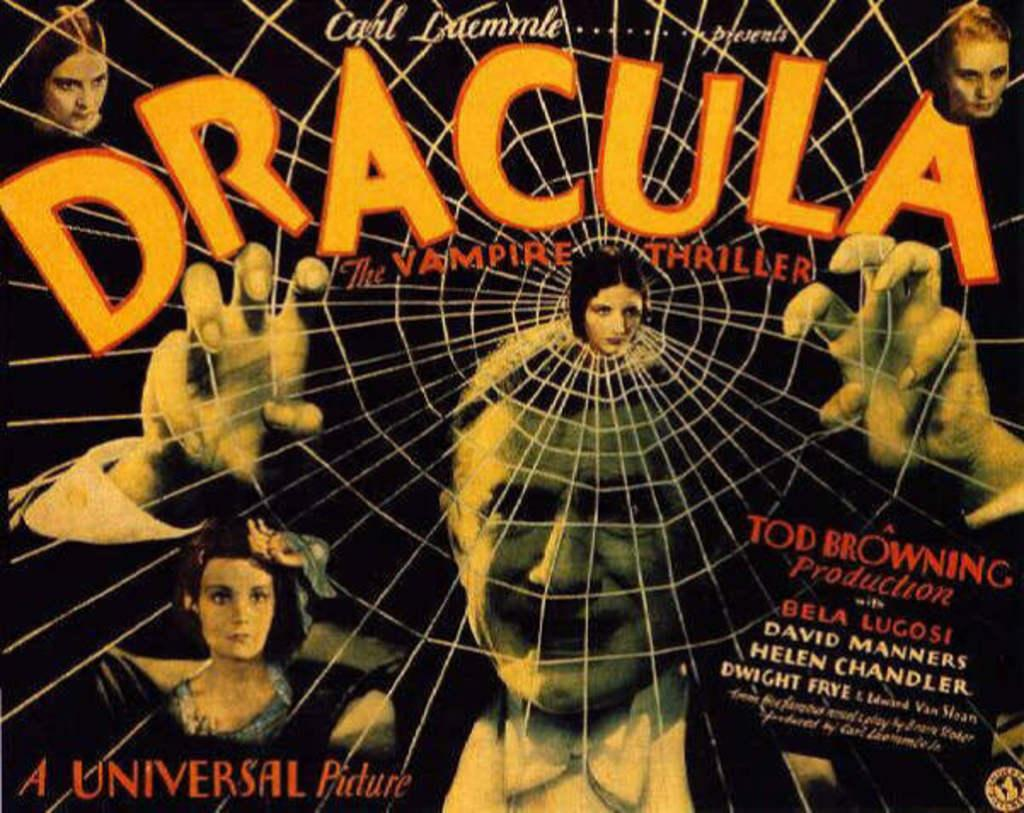<image>
Provide a brief description of the given image. A movie poster for the old Dracula movie. 